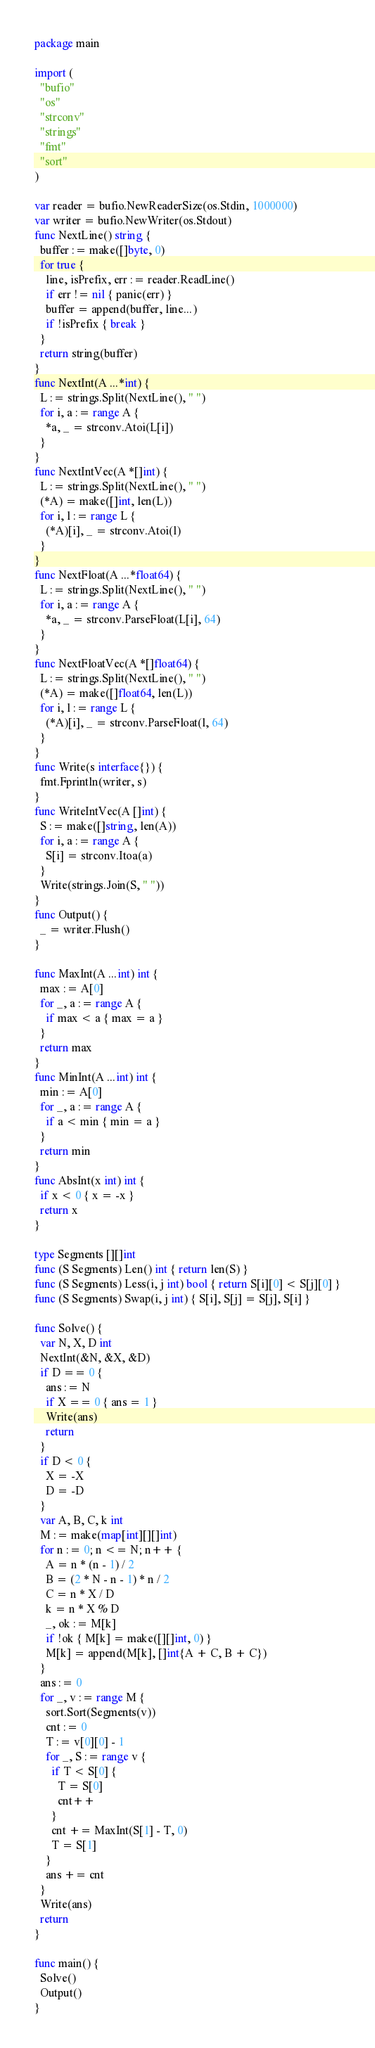<code> <loc_0><loc_0><loc_500><loc_500><_Go_>package main

import (
  "bufio"
  "os"
  "strconv"
  "strings"
  "fmt"
  "sort"
)

var reader = bufio.NewReaderSize(os.Stdin, 1000000)
var writer = bufio.NewWriter(os.Stdout)
func NextLine() string {
  buffer := make([]byte, 0)
  for true {
    line, isPrefix, err := reader.ReadLine()
    if err != nil { panic(err) }
    buffer = append(buffer, line...)
    if !isPrefix { break }
  }
  return string(buffer)
}
func NextInt(A ...*int) {
  L := strings.Split(NextLine(), " ")
  for i, a := range A {
    *a, _ = strconv.Atoi(L[i])
  }
}
func NextIntVec(A *[]int) {
  L := strings.Split(NextLine(), " ")
  (*A) = make([]int, len(L))
  for i, l := range L {
    (*A)[i], _ = strconv.Atoi(l)
  }
}
func NextFloat(A ...*float64) {
  L := strings.Split(NextLine(), " ")
  for i, a := range A {
    *a, _ = strconv.ParseFloat(L[i], 64)
  }
}
func NextFloatVec(A *[]float64) {
  L := strings.Split(NextLine(), " ")
  (*A) = make([]float64, len(L))
  for i, l := range L {
    (*A)[i], _ = strconv.ParseFloat(l, 64)
  }
}
func Write(s interface{}) {
  fmt.Fprintln(writer, s)
}
func WriteIntVec(A []int) {
  S := make([]string, len(A))
  for i, a := range A {
    S[i] = strconv.Itoa(a)
  }
  Write(strings.Join(S, " "))
}
func Output() {
  _ = writer.Flush()
}

func MaxInt(A ...int) int {
  max := A[0]
  for _, a := range A {
    if max < a { max = a }
  }
  return max
}
func MinInt(A ...int) int {
  min := A[0]
  for _, a := range A {
    if a < min { min = a }
  }
  return min
}
func AbsInt(x int) int {
  if x < 0 { x = -x }
  return x
}

type Segments [][]int
func (S Segments) Len() int { return len(S) }
func (S Segments) Less(i, j int) bool { return S[i][0] < S[j][0] }
func (S Segments) Swap(i, j int) { S[i], S[j] = S[j], S[i] }

func Solve() {
  var N, X, D int
  NextInt(&N, &X, &D)
  if D == 0 {
    ans := N
    if X == 0 { ans = 1 }
    Write(ans)
    return
  }
  if D < 0 {
    X = -X
    D = -D
  }
  var A, B, C, k int
  M := make(map[int][][]int)
  for n := 0; n <= N; n++ {
    A = n * (n - 1) / 2
    B = (2 * N - n - 1) * n / 2
    C = n * X / D
    k = n * X % D
    _, ok := M[k]
    if !ok { M[k] = make([][]int, 0) }
    M[k] = append(M[k], []int{A + C, B + C})
  }
  ans := 0
  for _, v := range M {
    sort.Sort(Segments(v))
    cnt := 0
    T := v[0][0] - 1
    for _, S := range v {
      if T < S[0] {
        T = S[0]
        cnt++
      }
      cnt += MaxInt(S[1] - T, 0)
      T = S[1]
    }
    ans += cnt
  }
  Write(ans)
  return
}

func main() {
  Solve()
  Output()
}</code> 